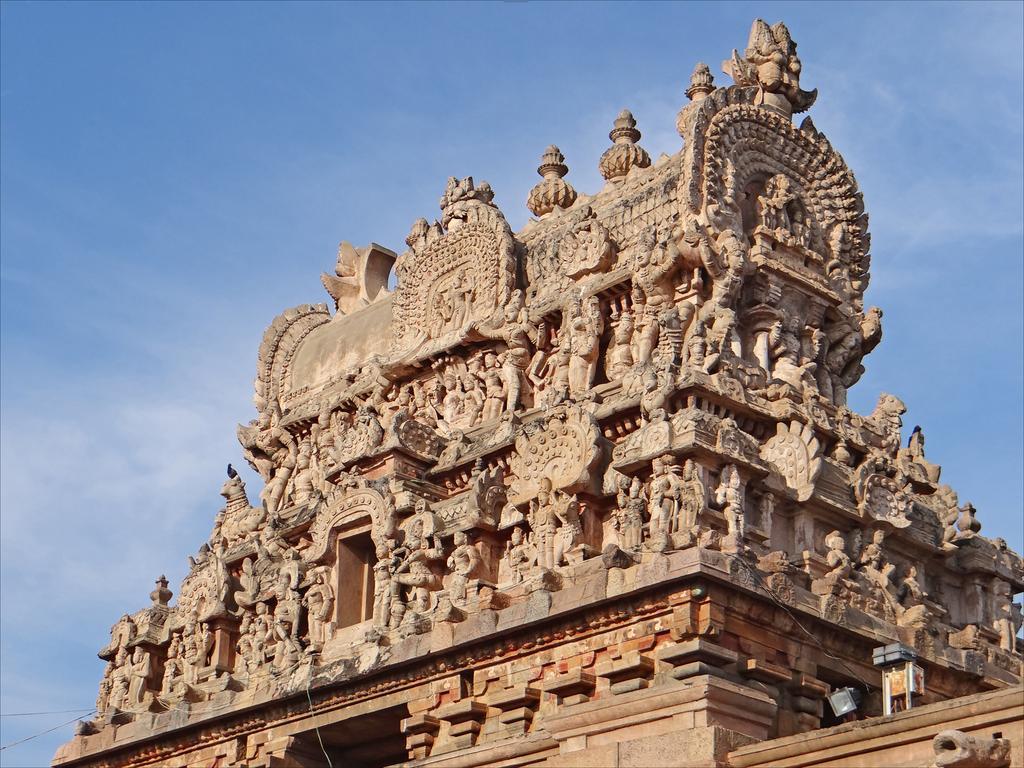Could you give a brief overview of what you see in this image? In this image there is a temple with sculptures, and in the background there is sky. 